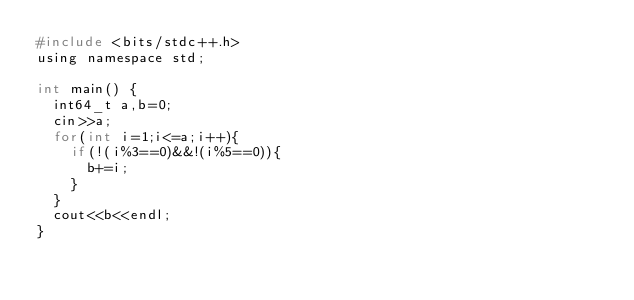<code> <loc_0><loc_0><loc_500><loc_500><_C_>#include <bits/stdc++.h>
using namespace std;

int main() {
  int64_t a,b=0;
  cin>>a;
  for(int i=1;i<=a;i++){
    if(!(i%3==0)&&!(i%5==0)){
      b+=i;
    }
  }
  cout<<b<<endl;
}</code> 